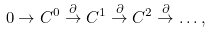<formula> <loc_0><loc_0><loc_500><loc_500>0 \rightarrow C ^ { 0 } \stackrel { \partial } { \rightarrow } C ^ { 1 } \stackrel { \partial } { \rightarrow } C ^ { 2 } \stackrel { \partial } { \rightarrow } \dots ,</formula> 